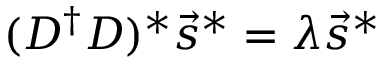Convert formula to latex. <formula><loc_0><loc_0><loc_500><loc_500>( D ^ { \dagger } D ) ^ { * } \vec { s } ^ { * } = \lambda \vec { s } ^ { * }</formula> 